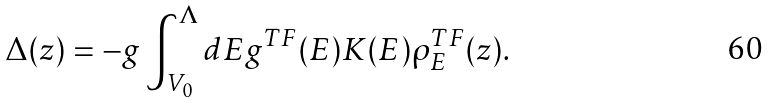<formula> <loc_0><loc_0><loc_500><loc_500>\Delta ( z ) = - g \int _ { V _ { 0 } } ^ { \Lambda } d E g ^ { T F } ( E ) K ( E ) \rho ^ { T F } _ { E } ( z ) .</formula> 